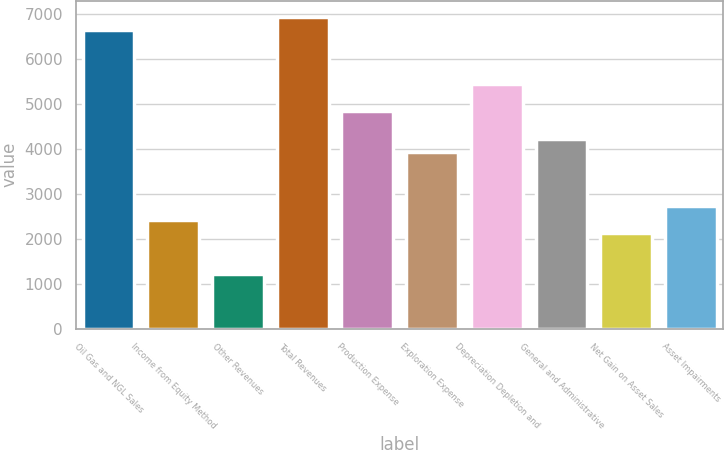Convert chart. <chart><loc_0><loc_0><loc_500><loc_500><bar_chart><fcel>Oil Gas and NGL Sales<fcel>Income from Equity Method<fcel>Other Revenues<fcel>Total Revenues<fcel>Production Expense<fcel>Exploration Expense<fcel>Depreciation Depletion and<fcel>General and Administrative<fcel>Net Gain on Asset Sales<fcel>Asset Impairments<nl><fcel>6643.48<fcel>2418.42<fcel>1211.26<fcel>6945.27<fcel>4832.74<fcel>3927.37<fcel>5436.32<fcel>4229.16<fcel>2116.63<fcel>2720.21<nl></chart> 